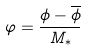<formula> <loc_0><loc_0><loc_500><loc_500>\varphi = \frac { \phi - \overline { \phi } } { M _ { * } }</formula> 